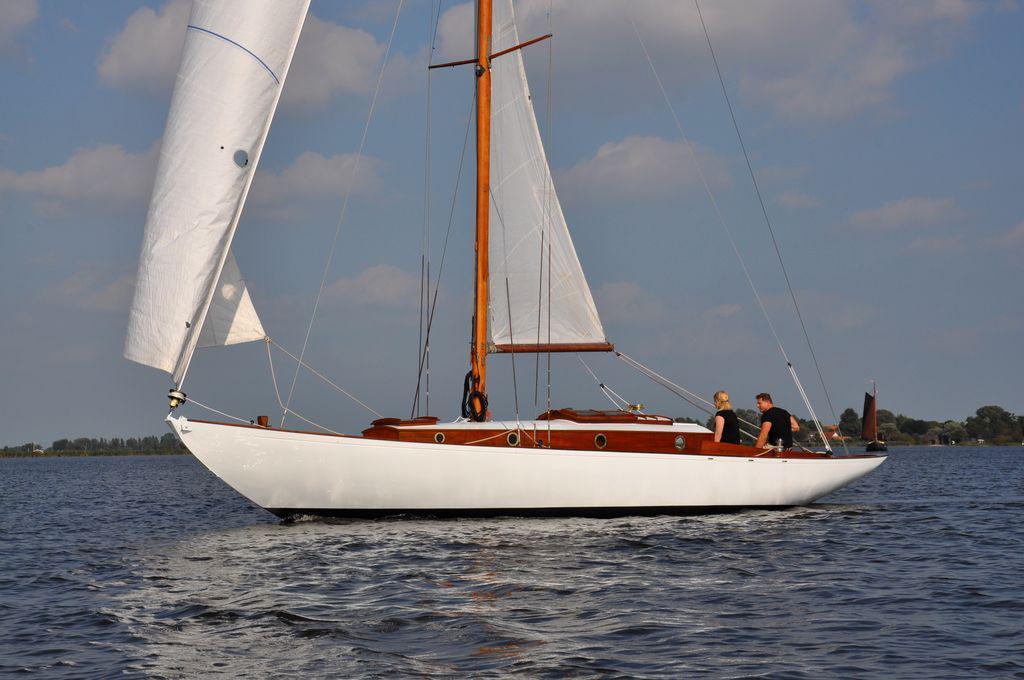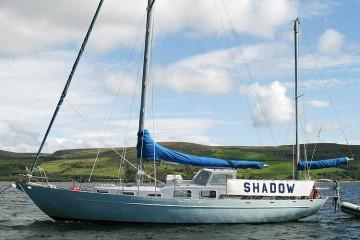The first image is the image on the left, the second image is the image on the right. For the images shown, is this caption "The sails are furled in the image on the left." true? Answer yes or no. No. 